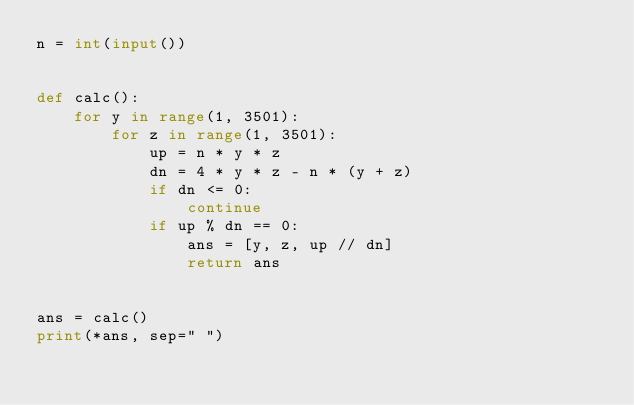<code> <loc_0><loc_0><loc_500><loc_500><_Python_>n = int(input())


def calc():
    for y in range(1, 3501):
        for z in range(1, 3501):
            up = n * y * z
            dn = 4 * y * z - n * (y + z)
            if dn <= 0:
                continue
            if up % dn == 0:
                ans = [y, z, up // dn]
                return ans


ans = calc()
print(*ans, sep=" ")
</code> 